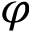Convert formula to latex. <formula><loc_0><loc_0><loc_500><loc_500>\varphi</formula> 